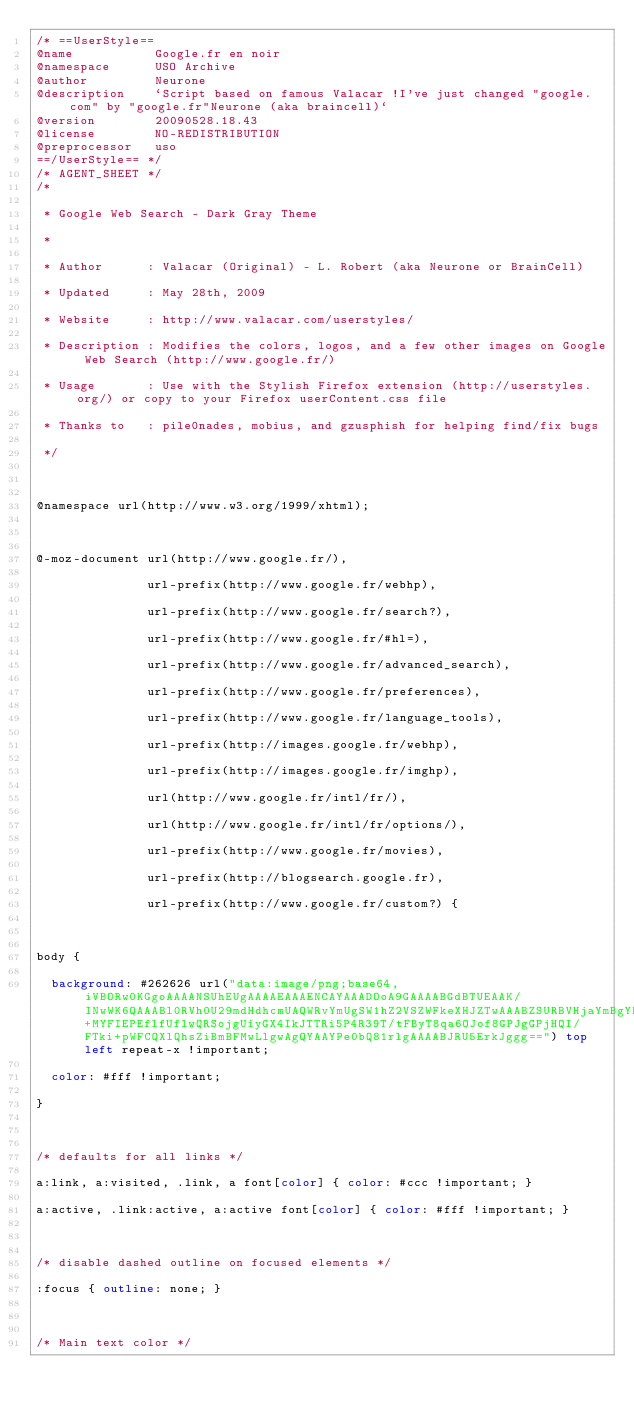Convert code to text. <code><loc_0><loc_0><loc_500><loc_500><_CSS_>/* ==UserStyle==
@name           Google.fr en noir
@namespace      USO Archive
@author         Neurone
@description    `Script based on famous Valacar !I've just changed "google.com" by "google.fr"Neurone (aka braincell)`
@version        20090528.18.43
@license        NO-REDISTRIBUTION
@preprocessor   uso
==/UserStyle== */
/* AGENT_SHEET */
/*

 * Google Web Search - Dark Gray Theme

 *

 * Author      : Valacar (Original) - L. Robert (aka Neurone or BrainCell)

 * Updated     : May 28th, 2009

 * Website     : http://www.valacar.com/userstyles/

 * Description : Modifies the colors, logos, and a few other images on Google Web Search (http://www.google.fr/)

 * Usage       : Use with the Stylish Firefox extension (http://userstyles.org/) or copy to your Firefox userContent.css file

 * Thanks to   : pile0nades, mobius, and gzusphish for helping find/fix bugs

 */



@namespace url(http://www.w3.org/1999/xhtml);



@-moz-document url(http://www.google.fr/),

               url-prefix(http://www.google.fr/webhp),

               url-prefix(http://www.google.fr/search?),

               url-prefix(http://www.google.fr/#hl=),

               url-prefix(http://www.google.fr/advanced_search),

               url-prefix(http://www.google.fr/preferences),

               url-prefix(http://www.google.fr/language_tools),

               url-prefix(http://images.google.fr/webhp),
               
               url-prefix(http://images.google.fr/imghp),
               
               url(http://www.google.fr/intl/fr/),
               
               url(http://www.google.fr/intl/fr/options/),

               url-prefix(http://www.google.fr/movies),

               url-prefix(http://blogsearch.google.fr),

               url-prefix(http://www.google.fr/custom?) {



body {

  background: #262626 url("data:image/png;base64,iVBORw0KGgoAAAANSUhEUgAAAAEAAAENCAYAAADOoA9GAAAABGdBTUEAAK/INwWK6QAAABl0RVh0U29mdHdhcmUAQWRvYmUgSW1hZ2VSZWFkeXHJZTwAAABZSURBVHjaYmBgYPjPACP+MYFIEPEflfUflwQRSojgUiyGX4IkJTTRi5P4R39T/tFByT8qa6OJof8GPJgGPjHQI/FTki+pWFCQXlQhsZiBmBFMwLlgwAgQYAAYPe0bQ81rlgAAAABJRU5ErkJggg==") top left repeat-x !important;

  color: #fff !important;

}



/* defaults for all links */

a:link, a:visited, .link, a font[color] { color: #ccc !important; }

a:active, .link:active, a:active font[color] { color: #fff !important; }



/* disable dashed outline on focused elements */

:focus { outline: none; }



/* Main text color */</code> 